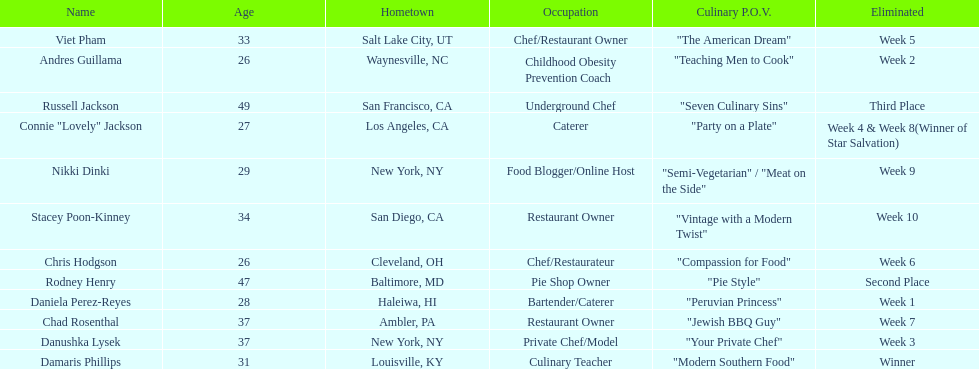Who was the top chef? Damaris Phillips. 